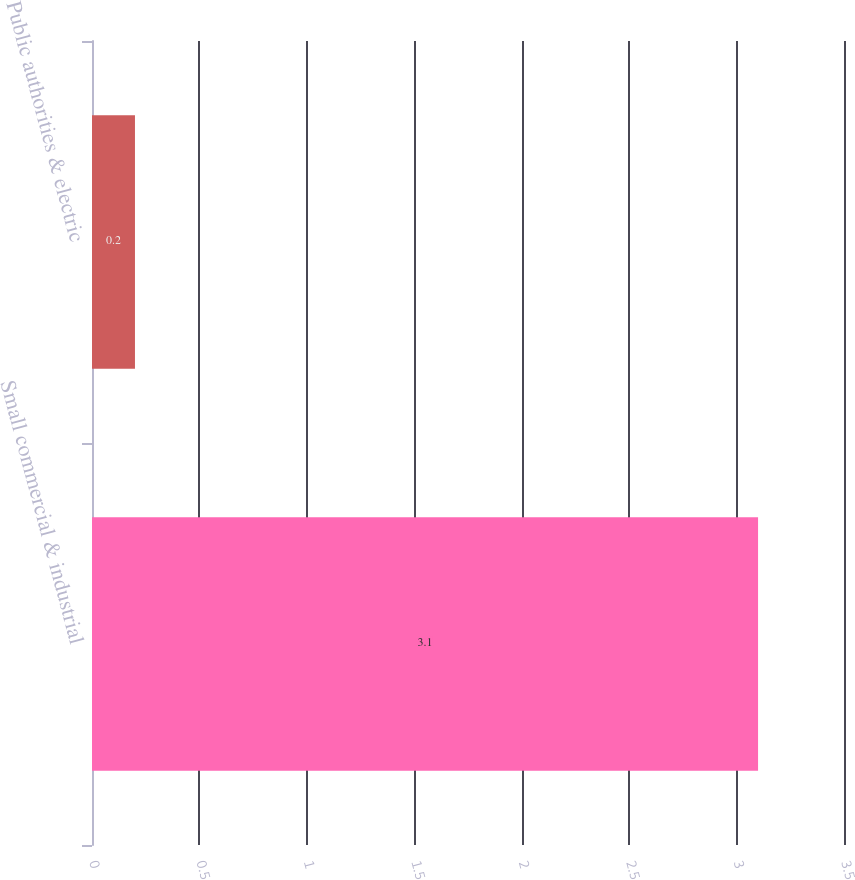<chart> <loc_0><loc_0><loc_500><loc_500><bar_chart><fcel>Small commercial & industrial<fcel>Public authorities & electric<nl><fcel>3.1<fcel>0.2<nl></chart> 